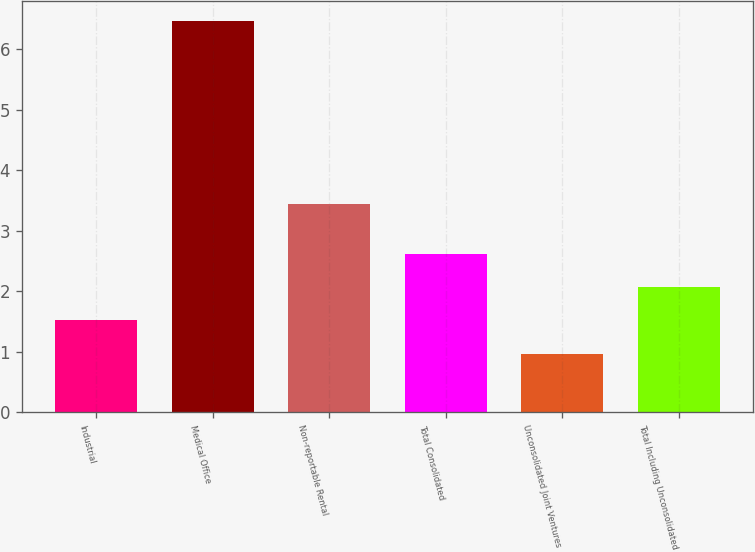<chart> <loc_0><loc_0><loc_500><loc_500><bar_chart><fcel>Industrial<fcel>Medical Office<fcel>Non-reportable Rental<fcel>Total Consolidated<fcel>Unconsolidated Joint Ventures<fcel>Total Including Unconsolidated<nl><fcel>1.52<fcel>6.47<fcel>3.44<fcel>2.62<fcel>0.97<fcel>2.07<nl></chart> 